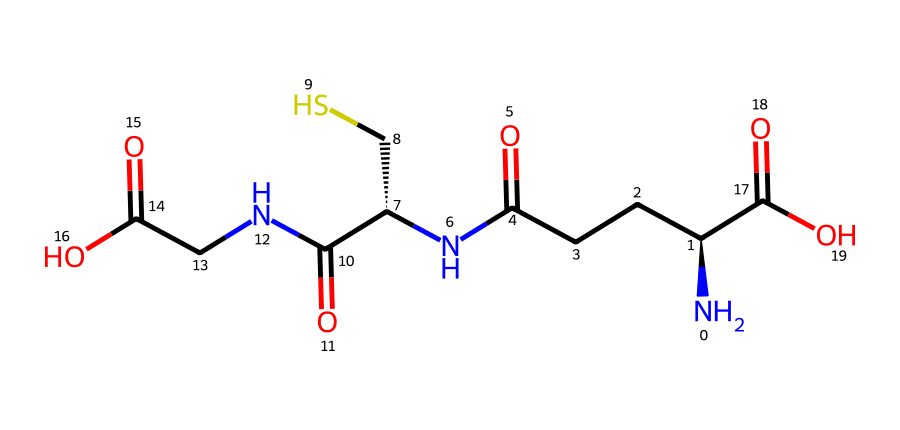What is the molecular formula of glutathione represented by this SMILES? By interpreting the SMILES notation, we can count the number of each type of atom present in the compound. Here, we have carbon (C), hydrogen (H), nitrogen (N), oxygen (O), and sulfur (S). Counting gives us C10, H17, N3, O6, S1.
Answer: C10H17N3O6S How many nitrogen atoms are present in the glutathione structure? From the SMILES representation, we can identify the nitrogen atoms. By observing the notation, we see three instances of nitrogen (N), therefore the total is three.
Answer: 3 What does the presence of sulfur in the structure indicate about the compound? The presence of sulfur is indicative of a thiol group present in the structure, which plays a critical role in the antioxidant activity of glutathione by participating in redox reactions.
Answer: antioxidant Which functional groups can be identified in this structure? Analyzing the structure reveals amino groups (-NH2), carboxylic acid groups (-COOH), and a thiol group (-SH), which are characteristic functional groups in glutathione.
Answer: -NH2, -COOH, -SH What is the role of glutathione in cellular processes? Glutathione serves as a primary antioxidant in cells, protecting them from oxidative stress by neutralizing free radicals and maintaining redox homeostasis.
Answer: antioxidant How many carboxylic acid groups are present in glutathione? The compound contains two carboxylic acid groups, derived from observing the two -COOH groups in the structure.
Answer: 2 What is the significance of the N-C bond in the context of glutathione's function? The N-C bonds in glutathione connect amino acids and are crucial for the structure of glutathione, allowing it to maintain its shape and function as an effective antioxidant.
Answer: structure 